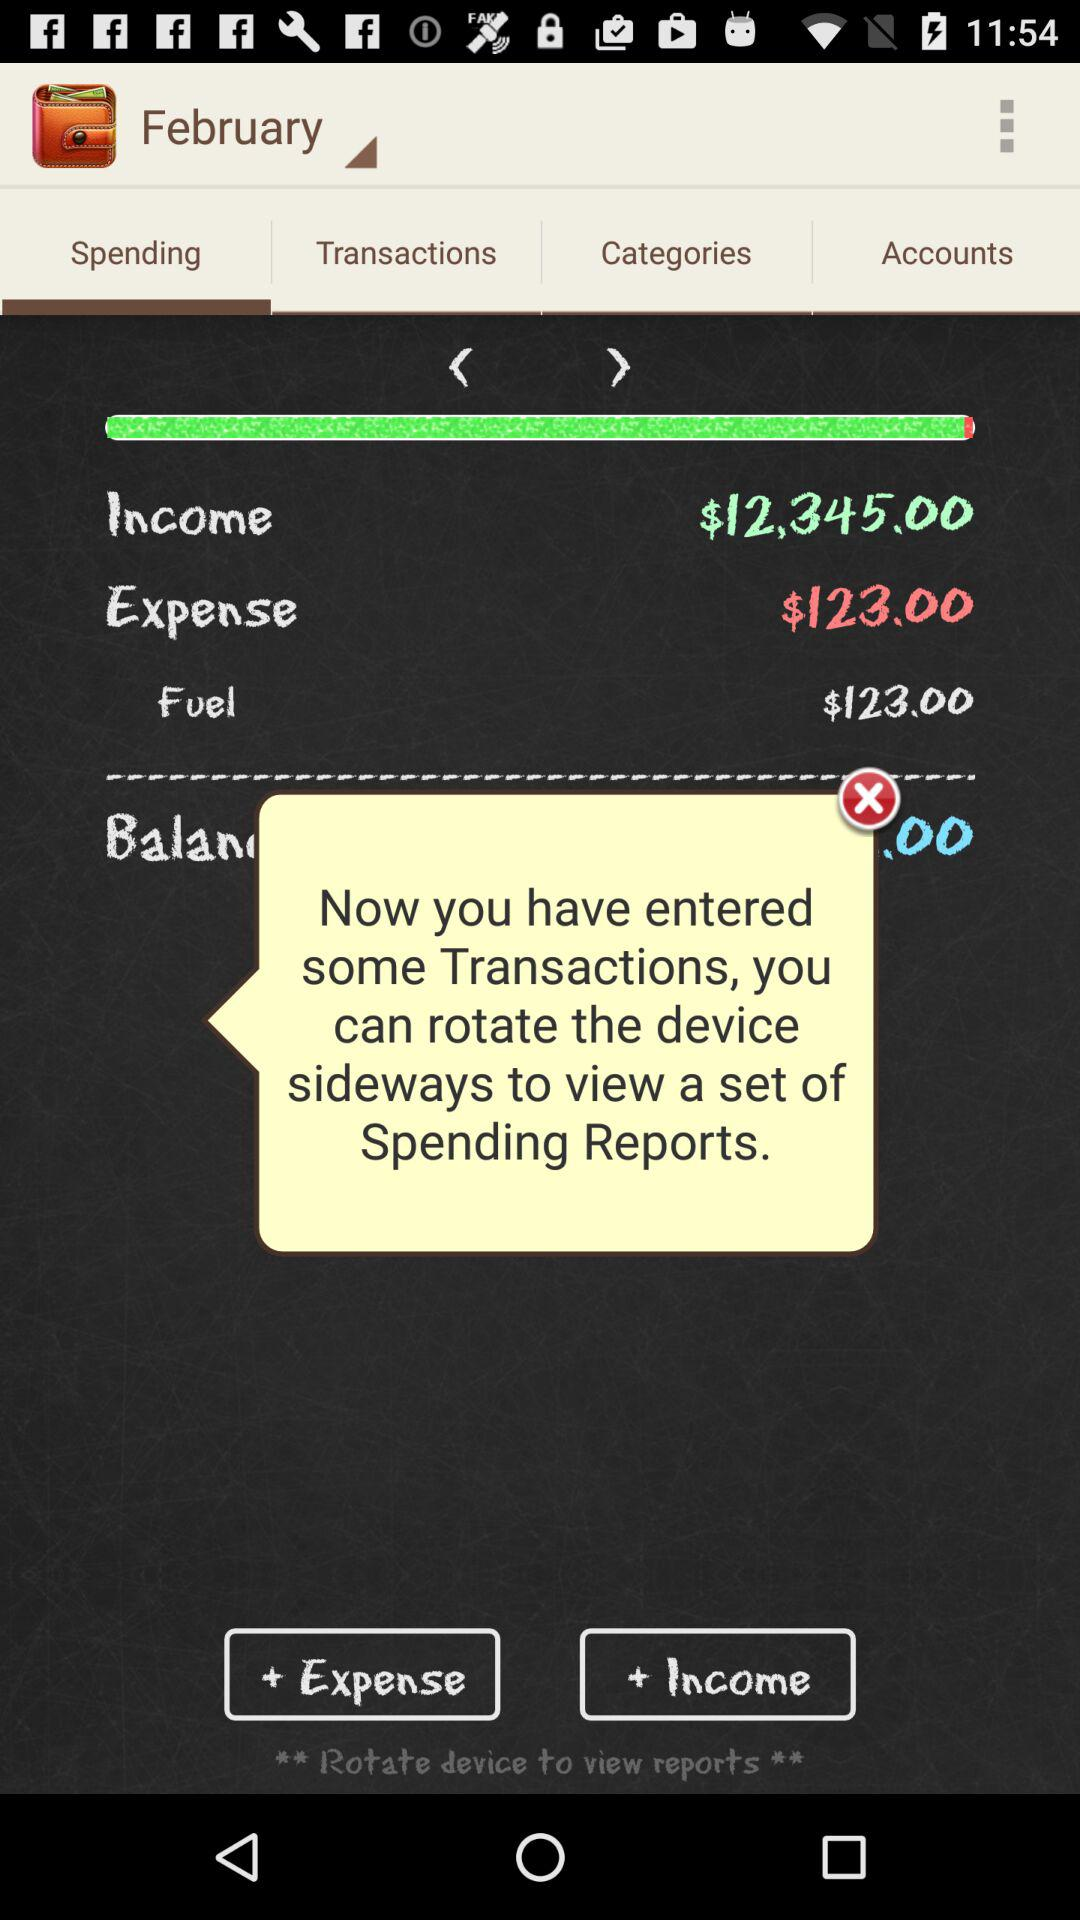What is the fuel price? The fuel price is $123. 